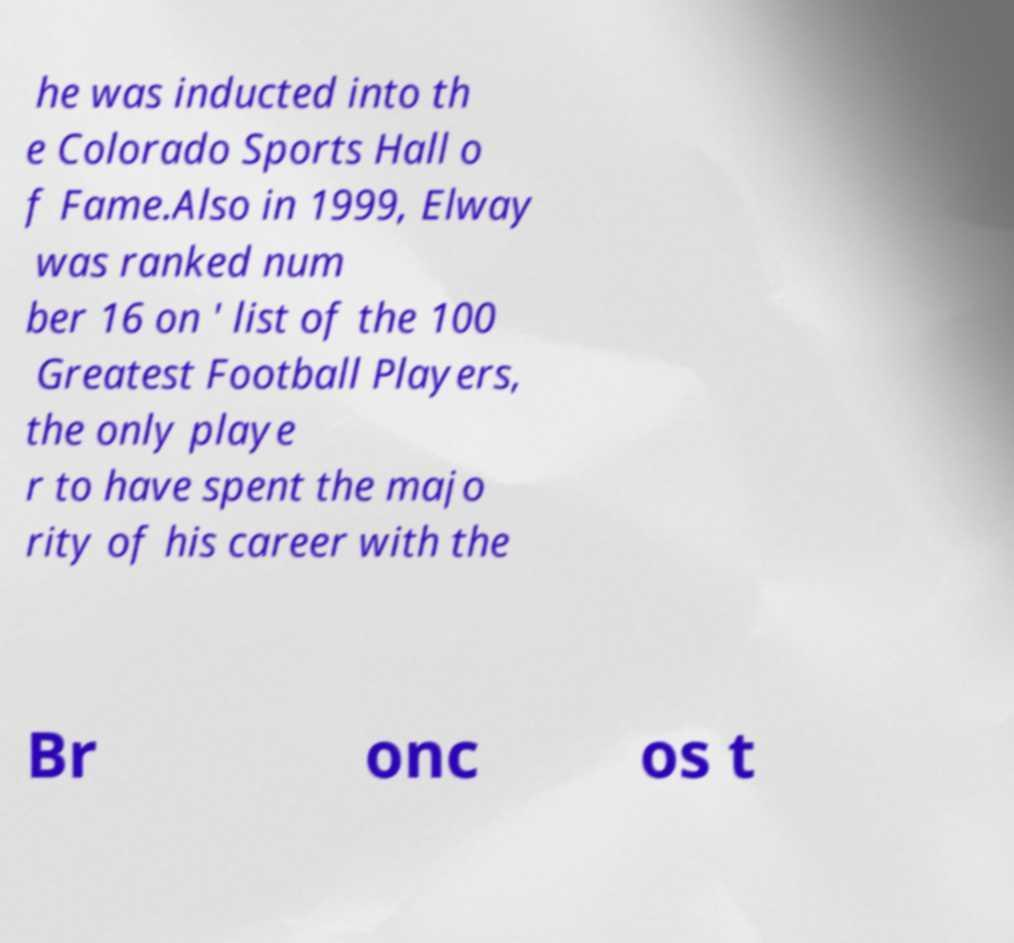There's text embedded in this image that I need extracted. Can you transcribe it verbatim? he was inducted into th e Colorado Sports Hall o f Fame.Also in 1999, Elway was ranked num ber 16 on ' list of the 100 Greatest Football Players, the only playe r to have spent the majo rity of his career with the Br onc os t 